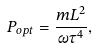Convert formula to latex. <formula><loc_0><loc_0><loc_500><loc_500>P _ { o p t } = \frac { m L ^ { 2 } } { \omega \tau ^ { 4 } } ,</formula> 